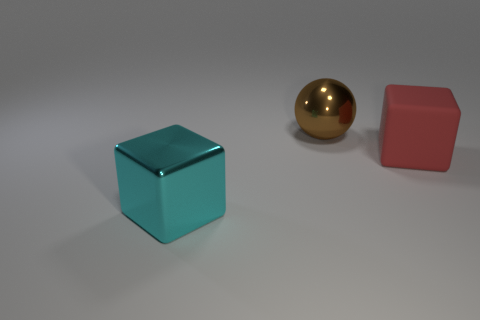Add 2 brown metallic spheres. How many objects exist? 5 Subtract all balls. How many objects are left? 2 Add 2 green cylinders. How many green cylinders exist? 2 Subtract 0 blue cylinders. How many objects are left? 3 Subtract all tiny yellow metallic cylinders. Subtract all cyan things. How many objects are left? 2 Add 1 brown spheres. How many brown spheres are left? 2 